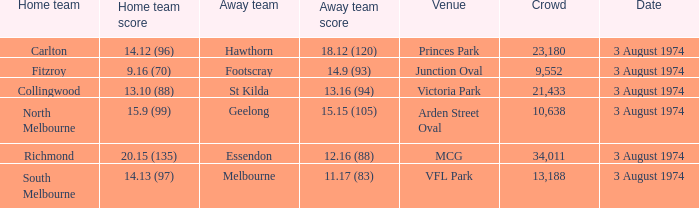Which Home team has a Venue of arden street oval? North Melbourne. 